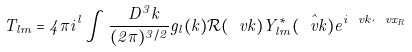<formula> <loc_0><loc_0><loc_500><loc_500>T _ { l m } = 4 \pi i ^ { l } \int \frac { \ D ^ { 3 } k } { ( 2 \pi ) ^ { 3 / 2 } } g _ { l } ( k ) \mathcal { R } ( \ v k ) Y _ { l m } ^ { * } ( \hat { \ v k } ) e ^ { i \ v k \cdot \ v x _ { R } }</formula> 